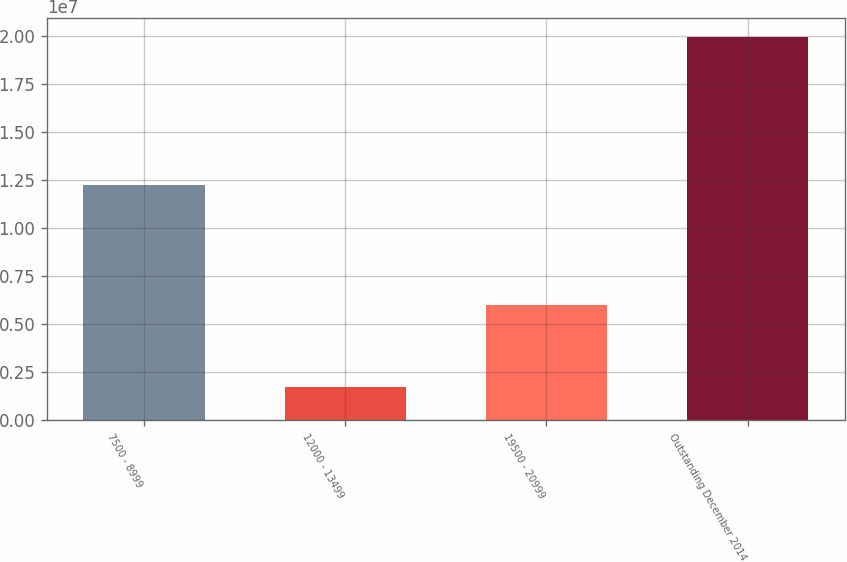Convert chart to OTSL. <chart><loc_0><loc_0><loc_500><loc_500><bar_chart><fcel>7500 - 8999<fcel>12000 - 13499<fcel>19500 - 20999<fcel>Outstanding December 2014<nl><fcel>1.22363e+07<fcel>1.73795e+06<fcel>5.98112e+06<fcel>1.99553e+07<nl></chart> 